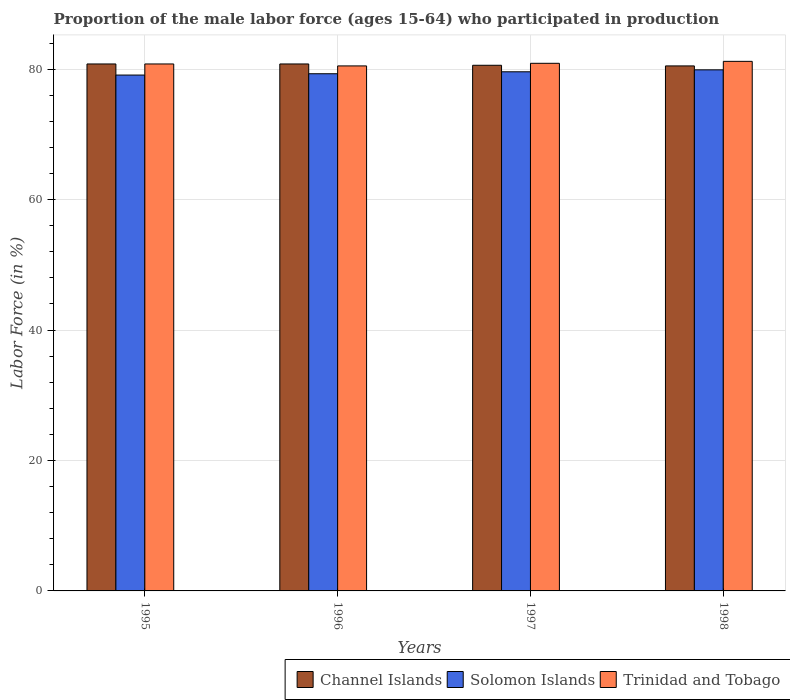Are the number of bars per tick equal to the number of legend labels?
Offer a very short reply. Yes. Are the number of bars on each tick of the X-axis equal?
Make the answer very short. Yes. How many bars are there on the 3rd tick from the right?
Provide a short and direct response. 3. What is the proportion of the male labor force who participated in production in Trinidad and Tobago in 1996?
Keep it short and to the point. 80.5. Across all years, what is the maximum proportion of the male labor force who participated in production in Trinidad and Tobago?
Ensure brevity in your answer.  81.2. Across all years, what is the minimum proportion of the male labor force who participated in production in Trinidad and Tobago?
Offer a very short reply. 80.5. In which year was the proportion of the male labor force who participated in production in Trinidad and Tobago maximum?
Offer a very short reply. 1998. In which year was the proportion of the male labor force who participated in production in Solomon Islands minimum?
Ensure brevity in your answer.  1995. What is the total proportion of the male labor force who participated in production in Solomon Islands in the graph?
Give a very brief answer. 317.9. What is the difference between the proportion of the male labor force who participated in production in Trinidad and Tobago in 1995 and that in 1997?
Provide a succinct answer. -0.1. What is the difference between the proportion of the male labor force who participated in production in Trinidad and Tobago in 1996 and the proportion of the male labor force who participated in production in Solomon Islands in 1995?
Your answer should be compact. 1.4. What is the average proportion of the male labor force who participated in production in Trinidad and Tobago per year?
Provide a short and direct response. 80.85. In how many years, is the proportion of the male labor force who participated in production in Solomon Islands greater than 40 %?
Provide a short and direct response. 4. What is the ratio of the proportion of the male labor force who participated in production in Trinidad and Tobago in 1996 to that in 1997?
Provide a short and direct response. 1. What is the difference between the highest and the second highest proportion of the male labor force who participated in production in Trinidad and Tobago?
Keep it short and to the point. 0.3. What is the difference between the highest and the lowest proportion of the male labor force who participated in production in Channel Islands?
Make the answer very short. 0.3. Is the sum of the proportion of the male labor force who participated in production in Trinidad and Tobago in 1995 and 1997 greater than the maximum proportion of the male labor force who participated in production in Solomon Islands across all years?
Your answer should be very brief. Yes. What does the 3rd bar from the left in 1995 represents?
Your answer should be very brief. Trinidad and Tobago. What does the 2nd bar from the right in 1997 represents?
Your answer should be compact. Solomon Islands. What is the difference between two consecutive major ticks on the Y-axis?
Your answer should be compact. 20. How many legend labels are there?
Ensure brevity in your answer.  3. What is the title of the graph?
Offer a very short reply. Proportion of the male labor force (ages 15-64) who participated in production. Does "Haiti" appear as one of the legend labels in the graph?
Keep it short and to the point. No. What is the label or title of the Y-axis?
Your answer should be compact. Labor Force (in %). What is the Labor Force (in %) of Channel Islands in 1995?
Your response must be concise. 80.8. What is the Labor Force (in %) of Solomon Islands in 1995?
Provide a succinct answer. 79.1. What is the Labor Force (in %) in Trinidad and Tobago in 1995?
Offer a terse response. 80.8. What is the Labor Force (in %) of Channel Islands in 1996?
Ensure brevity in your answer.  80.8. What is the Labor Force (in %) in Solomon Islands in 1996?
Ensure brevity in your answer.  79.3. What is the Labor Force (in %) in Trinidad and Tobago in 1996?
Make the answer very short. 80.5. What is the Labor Force (in %) of Channel Islands in 1997?
Offer a very short reply. 80.6. What is the Labor Force (in %) of Solomon Islands in 1997?
Your answer should be compact. 79.6. What is the Labor Force (in %) in Trinidad and Tobago in 1997?
Provide a succinct answer. 80.9. What is the Labor Force (in %) of Channel Islands in 1998?
Ensure brevity in your answer.  80.5. What is the Labor Force (in %) of Solomon Islands in 1998?
Keep it short and to the point. 79.9. What is the Labor Force (in %) in Trinidad and Tobago in 1998?
Your response must be concise. 81.2. Across all years, what is the maximum Labor Force (in %) in Channel Islands?
Your answer should be very brief. 80.8. Across all years, what is the maximum Labor Force (in %) in Solomon Islands?
Ensure brevity in your answer.  79.9. Across all years, what is the maximum Labor Force (in %) of Trinidad and Tobago?
Make the answer very short. 81.2. Across all years, what is the minimum Labor Force (in %) of Channel Islands?
Your answer should be compact. 80.5. Across all years, what is the minimum Labor Force (in %) of Solomon Islands?
Offer a terse response. 79.1. Across all years, what is the minimum Labor Force (in %) of Trinidad and Tobago?
Offer a very short reply. 80.5. What is the total Labor Force (in %) of Channel Islands in the graph?
Offer a terse response. 322.7. What is the total Labor Force (in %) of Solomon Islands in the graph?
Offer a terse response. 317.9. What is the total Labor Force (in %) in Trinidad and Tobago in the graph?
Make the answer very short. 323.4. What is the difference between the Labor Force (in %) in Channel Islands in 1995 and that in 1996?
Your answer should be very brief. 0. What is the difference between the Labor Force (in %) in Solomon Islands in 1995 and that in 1996?
Your answer should be very brief. -0.2. What is the difference between the Labor Force (in %) in Trinidad and Tobago in 1995 and that in 1996?
Provide a short and direct response. 0.3. What is the difference between the Labor Force (in %) in Channel Islands in 1995 and that in 1998?
Your response must be concise. 0.3. What is the difference between the Labor Force (in %) in Solomon Islands in 1995 and that in 1998?
Provide a succinct answer. -0.8. What is the difference between the Labor Force (in %) of Trinidad and Tobago in 1995 and that in 1998?
Give a very brief answer. -0.4. What is the difference between the Labor Force (in %) of Channel Islands in 1996 and that in 1998?
Offer a very short reply. 0.3. What is the difference between the Labor Force (in %) of Solomon Islands in 1996 and that in 1998?
Make the answer very short. -0.6. What is the difference between the Labor Force (in %) of Trinidad and Tobago in 1996 and that in 1998?
Offer a very short reply. -0.7. What is the difference between the Labor Force (in %) of Solomon Islands in 1997 and that in 1998?
Make the answer very short. -0.3. What is the difference between the Labor Force (in %) in Channel Islands in 1995 and the Labor Force (in %) in Trinidad and Tobago in 1996?
Offer a terse response. 0.3. What is the difference between the Labor Force (in %) of Channel Islands in 1995 and the Labor Force (in %) of Solomon Islands in 1997?
Your answer should be very brief. 1.2. What is the difference between the Labor Force (in %) in Solomon Islands in 1995 and the Labor Force (in %) in Trinidad and Tobago in 1997?
Give a very brief answer. -1.8. What is the difference between the Labor Force (in %) in Channel Islands in 1995 and the Labor Force (in %) in Solomon Islands in 1998?
Provide a succinct answer. 0.9. What is the difference between the Labor Force (in %) of Channel Islands in 1995 and the Labor Force (in %) of Trinidad and Tobago in 1998?
Give a very brief answer. -0.4. What is the difference between the Labor Force (in %) of Channel Islands in 1996 and the Labor Force (in %) of Solomon Islands in 1997?
Your response must be concise. 1.2. What is the difference between the Labor Force (in %) of Channel Islands in 1996 and the Labor Force (in %) of Trinidad and Tobago in 1997?
Offer a terse response. -0.1. What is the difference between the Labor Force (in %) in Channel Islands in 1996 and the Labor Force (in %) in Solomon Islands in 1998?
Give a very brief answer. 0.9. What is the difference between the Labor Force (in %) in Solomon Islands in 1997 and the Labor Force (in %) in Trinidad and Tobago in 1998?
Keep it short and to the point. -1.6. What is the average Labor Force (in %) in Channel Islands per year?
Offer a terse response. 80.67. What is the average Labor Force (in %) in Solomon Islands per year?
Provide a succinct answer. 79.47. What is the average Labor Force (in %) in Trinidad and Tobago per year?
Your answer should be compact. 80.85. In the year 1995, what is the difference between the Labor Force (in %) in Channel Islands and Labor Force (in %) in Solomon Islands?
Provide a short and direct response. 1.7. In the year 1995, what is the difference between the Labor Force (in %) in Solomon Islands and Labor Force (in %) in Trinidad and Tobago?
Make the answer very short. -1.7. In the year 1996, what is the difference between the Labor Force (in %) in Solomon Islands and Labor Force (in %) in Trinidad and Tobago?
Provide a short and direct response. -1.2. In the year 1998, what is the difference between the Labor Force (in %) in Solomon Islands and Labor Force (in %) in Trinidad and Tobago?
Offer a terse response. -1.3. What is the ratio of the Labor Force (in %) in Channel Islands in 1995 to that in 1996?
Your response must be concise. 1. What is the ratio of the Labor Force (in %) of Channel Islands in 1995 to that in 1997?
Your answer should be very brief. 1. What is the ratio of the Labor Force (in %) of Trinidad and Tobago in 1995 to that in 1997?
Make the answer very short. 1. What is the ratio of the Labor Force (in %) of Channel Islands in 1995 to that in 1998?
Keep it short and to the point. 1. What is the ratio of the Labor Force (in %) of Trinidad and Tobago in 1995 to that in 1998?
Make the answer very short. 1. What is the ratio of the Labor Force (in %) of Channel Islands in 1996 to that in 1997?
Your answer should be compact. 1. What is the ratio of the Labor Force (in %) in Solomon Islands in 1996 to that in 1997?
Offer a terse response. 1. What is the ratio of the Labor Force (in %) of Channel Islands in 1996 to that in 1998?
Your response must be concise. 1. What is the ratio of the Labor Force (in %) of Solomon Islands in 1996 to that in 1998?
Provide a short and direct response. 0.99. What is the ratio of the Labor Force (in %) of Channel Islands in 1997 to that in 1998?
Offer a terse response. 1. What is the ratio of the Labor Force (in %) of Solomon Islands in 1997 to that in 1998?
Provide a short and direct response. 1. What is the ratio of the Labor Force (in %) in Trinidad and Tobago in 1997 to that in 1998?
Your response must be concise. 1. What is the difference between the highest and the second highest Labor Force (in %) of Solomon Islands?
Your answer should be compact. 0.3. What is the difference between the highest and the second highest Labor Force (in %) in Trinidad and Tobago?
Your response must be concise. 0.3. What is the difference between the highest and the lowest Labor Force (in %) of Solomon Islands?
Offer a terse response. 0.8. What is the difference between the highest and the lowest Labor Force (in %) of Trinidad and Tobago?
Your response must be concise. 0.7. 